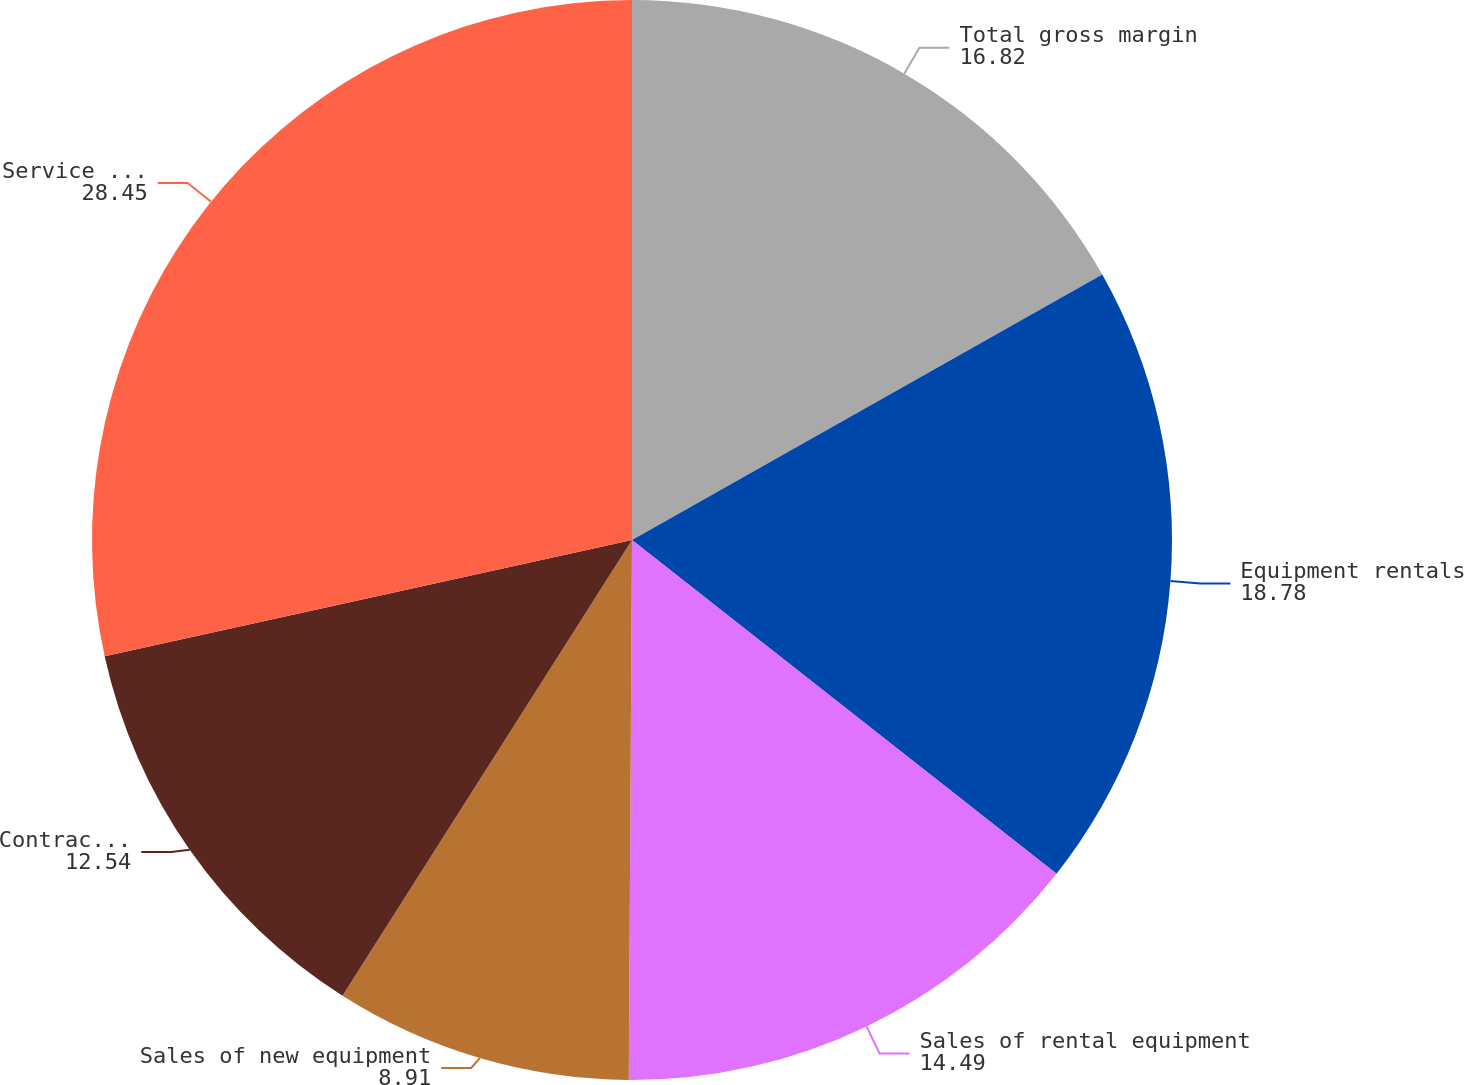<chart> <loc_0><loc_0><loc_500><loc_500><pie_chart><fcel>Total gross margin<fcel>Equipment rentals<fcel>Sales of rental equipment<fcel>Sales of new equipment<fcel>Contractor supplies sales<fcel>Service and other revenues<nl><fcel>16.82%<fcel>18.78%<fcel>14.49%<fcel>8.91%<fcel>12.54%<fcel>28.45%<nl></chart> 